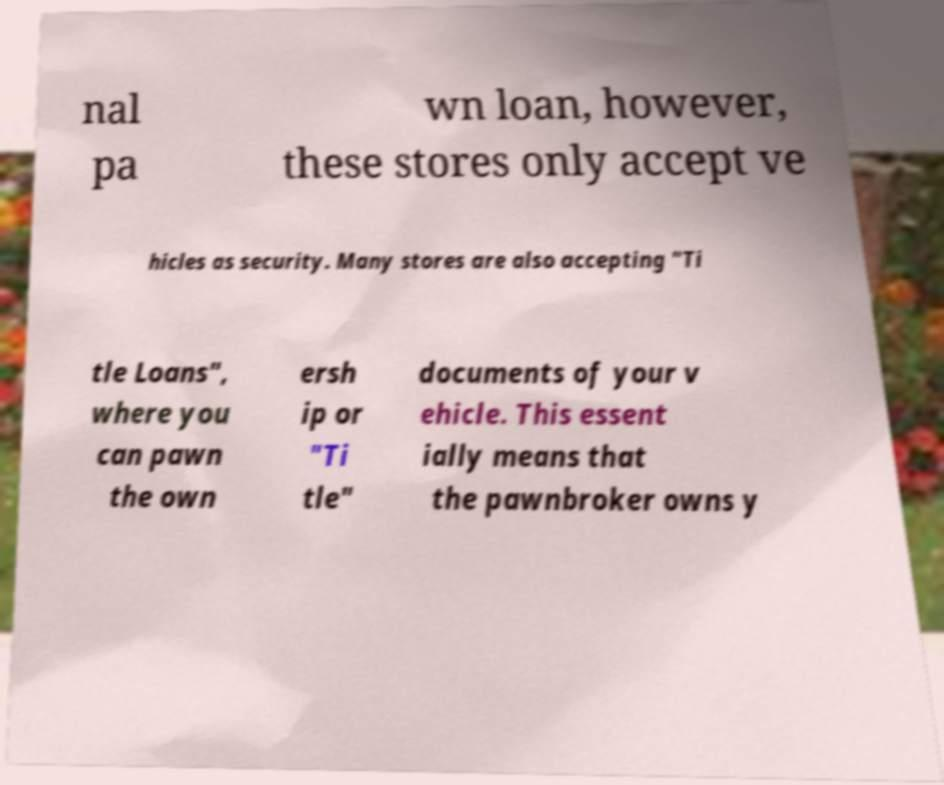There's text embedded in this image that I need extracted. Can you transcribe it verbatim? nal pa wn loan, however, these stores only accept ve hicles as security. Many stores are also accepting "Ti tle Loans", where you can pawn the own ersh ip or "Ti tle" documents of your v ehicle. This essent ially means that the pawnbroker owns y 